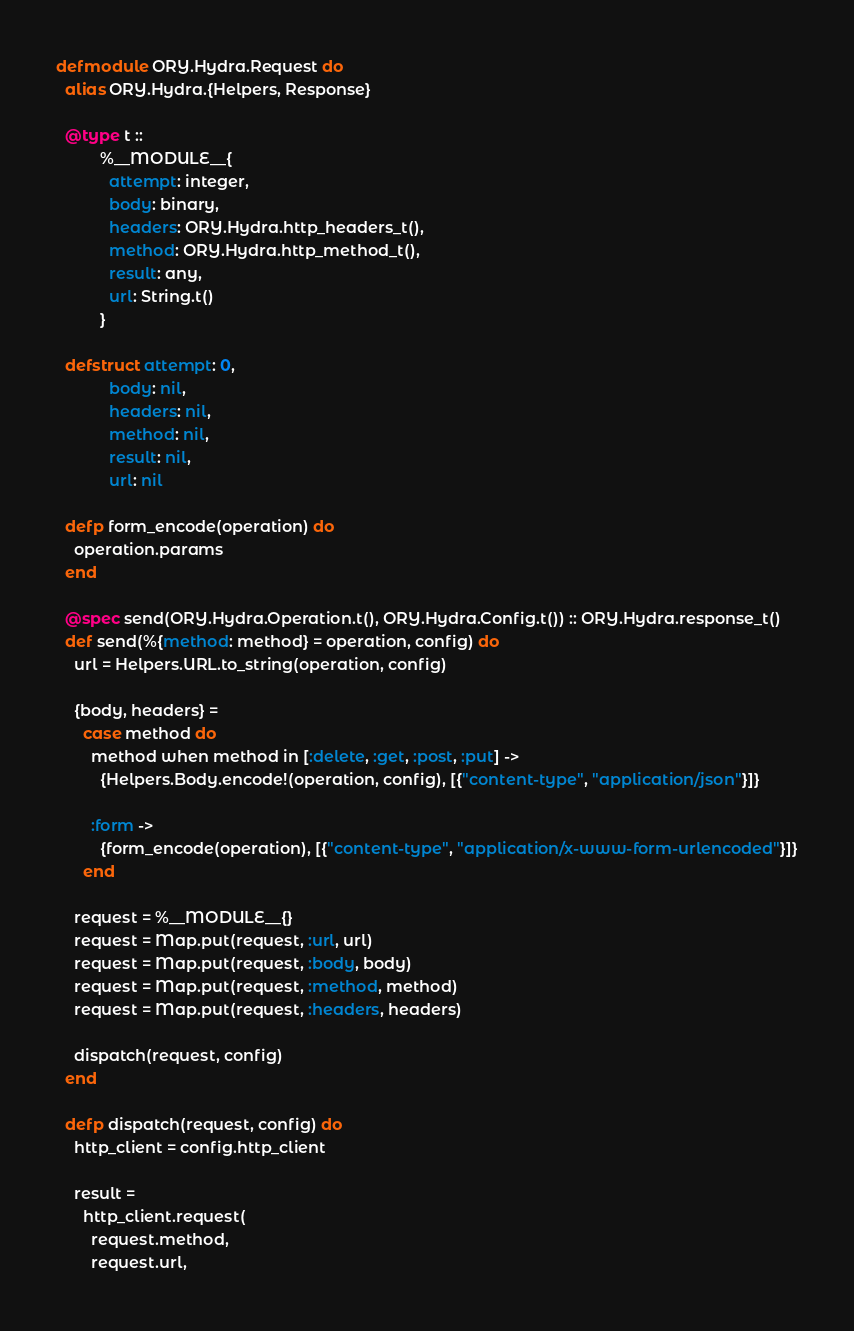<code> <loc_0><loc_0><loc_500><loc_500><_Elixir_>defmodule ORY.Hydra.Request do
  alias ORY.Hydra.{Helpers, Response}

  @type t ::
          %__MODULE__{
            attempt: integer,
            body: binary,
            headers: ORY.Hydra.http_headers_t(),
            method: ORY.Hydra.http_method_t(),
            result: any,
            url: String.t()
          }

  defstruct attempt: 0,
            body: nil,
            headers: nil,
            method: nil,
            result: nil,
            url: nil

  defp form_encode(operation) do
    operation.params
  end

  @spec send(ORY.Hydra.Operation.t(), ORY.Hydra.Config.t()) :: ORY.Hydra.response_t()
  def send(%{method: method} = operation, config) do
    url = Helpers.URL.to_string(operation, config)

    {body, headers} =
      case method do
        method when method in [:delete, :get, :post, :put] ->
          {Helpers.Body.encode!(operation, config), [{"content-type", "application/json"}]}

        :form ->
          {form_encode(operation), [{"content-type", "application/x-www-form-urlencoded"}]}
      end

    request = %__MODULE__{}
    request = Map.put(request, :url, url)
    request = Map.put(request, :body, body)
    request = Map.put(request, :method, method)
    request = Map.put(request, :headers, headers)

    dispatch(request, config)
  end

  defp dispatch(request, config) do
    http_client = config.http_client

    result =
      http_client.request(
        request.method,
        request.url,</code> 